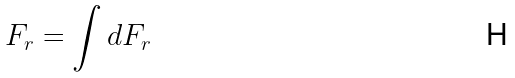Convert formula to latex. <formula><loc_0><loc_0><loc_500><loc_500>F _ { r } = \int d F _ { r }</formula> 